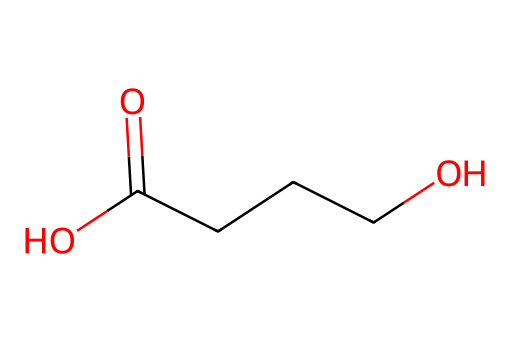What is the molecular formula of gamma-hydroxybutyric acid? The SMILES representation indicates the presence of 4 carbon atoms (C), 8 hydrogen atoms (H), and 3 oxygen atoms (O) based on the structure derived from the notation. This corresponds to the molecular formula C4H8O3.
Answer: C4H8O3 How many hydroxyl (–OH) groups are present in this compound? By analyzing the structure, one can identify the presence of one hydroxyl (–OH) group attached to the carbon chain, which is a characteristic feature of gamma-hydroxybutyric acid.
Answer: 1 What type of functional group is exhibited by this compound? The structure reveals a carboxylic acid functional group (-COOH) at one end and an alcohol functional group (-OH) within the chain, showing that this compound contains both functional groups.
Answer: carboxylic acid Is gamma-hydroxybutyric acid a simple or a cyclic compound? The SMILES representation shows a straight chain of carbons without any rings, indicating that it is not cyclic. It is a linear or simple compound.
Answer: simple What type of reaction is likely to modify gamma-hydroxybutyric acid? Given that this compound has functional groups like hydroxyl and carboxylic acid, it is likely to participate in esterification or dehydration reactions, common for compounds containing these functional groups.
Answer: esterification What is the role of gamma-hydroxybutyric acid in forensic toxicology? gamma-Hydroxybutyric acid is commonly known for its misuse as a date rape drug, as it can cause sedation and amnesia when ingested, making it significant in forensic investigations related to drug-facilitated crimes.
Answer: date rape drug What is the stereochemistry of gamma-hydroxybutyric acid? The structure lacks any chiral centers, which typically would indicate the presence of stereoisomers. Therefore, gamma-hydroxybutyric acid does not exhibit stereochemistry.
Answer: none 